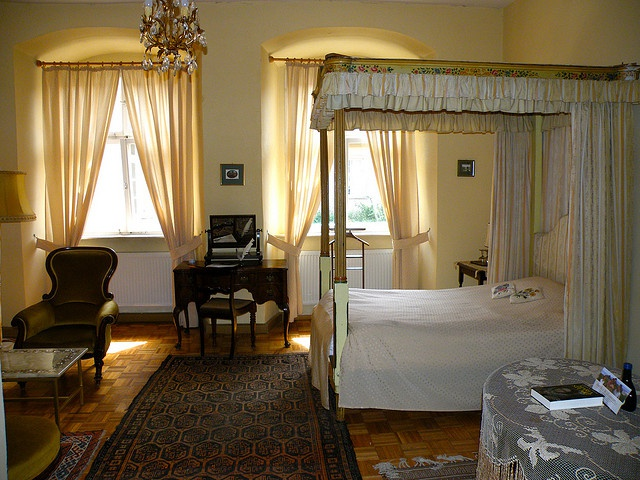Describe the objects in this image and their specific colors. I can see bed in black, gray, olive, and tan tones, dining table in black, gray, darkgray, and darkgreen tones, chair in black, maroon, olive, and tan tones, chair in black, maroon, gray, and olive tones, and book in black, lightblue, and darkgray tones in this image. 